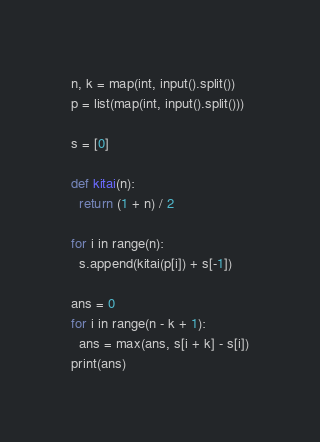Convert code to text. <code><loc_0><loc_0><loc_500><loc_500><_Python_>n, k = map(int, input().split())
p = list(map(int, input().split()))

s = [0]

def kitai(n):
  return (1 + n) / 2

for i in range(n):
  s.append(kitai(p[i]) + s[-1])

ans = 0
for i in range(n - k + 1):
  ans = max(ans, s[i + k] - s[i])
print(ans)</code> 